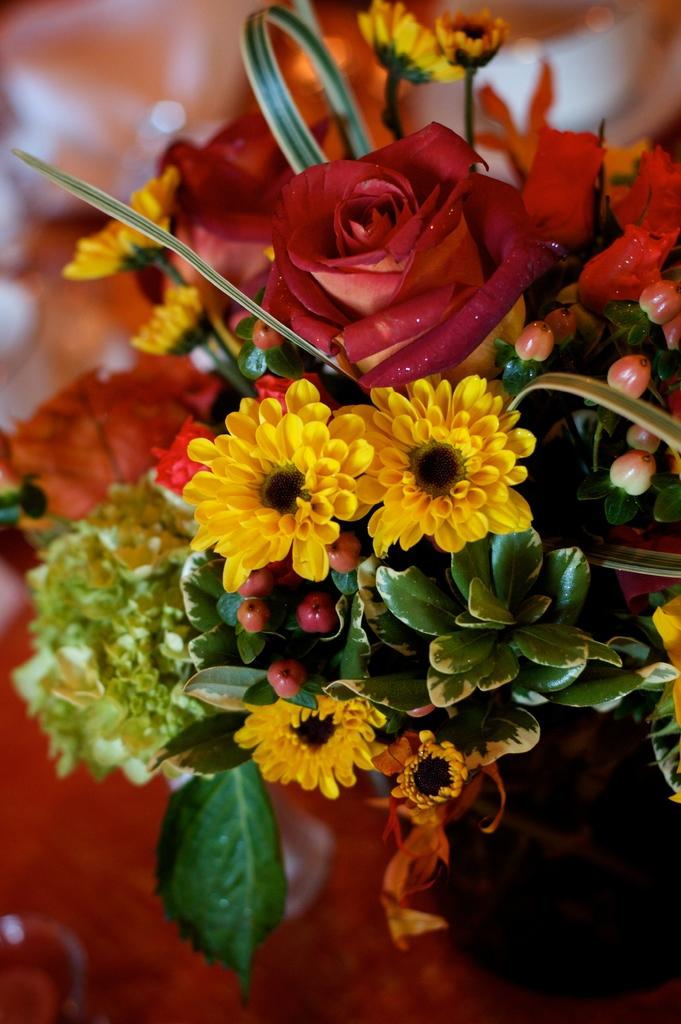What type of plant life is visible in the image? There are flowers and leaves of a plant pot in the image. Can you describe the flowers in the image? Unfortunately, the facts provided do not give specific details about the flowers. What is the context of the image? The facts provided do not give information about the context of the image. What type of crown is the gold statue wearing in the image? There is no mention of a crown or a gold statue in the provided facts, so this question cannot be answered. 